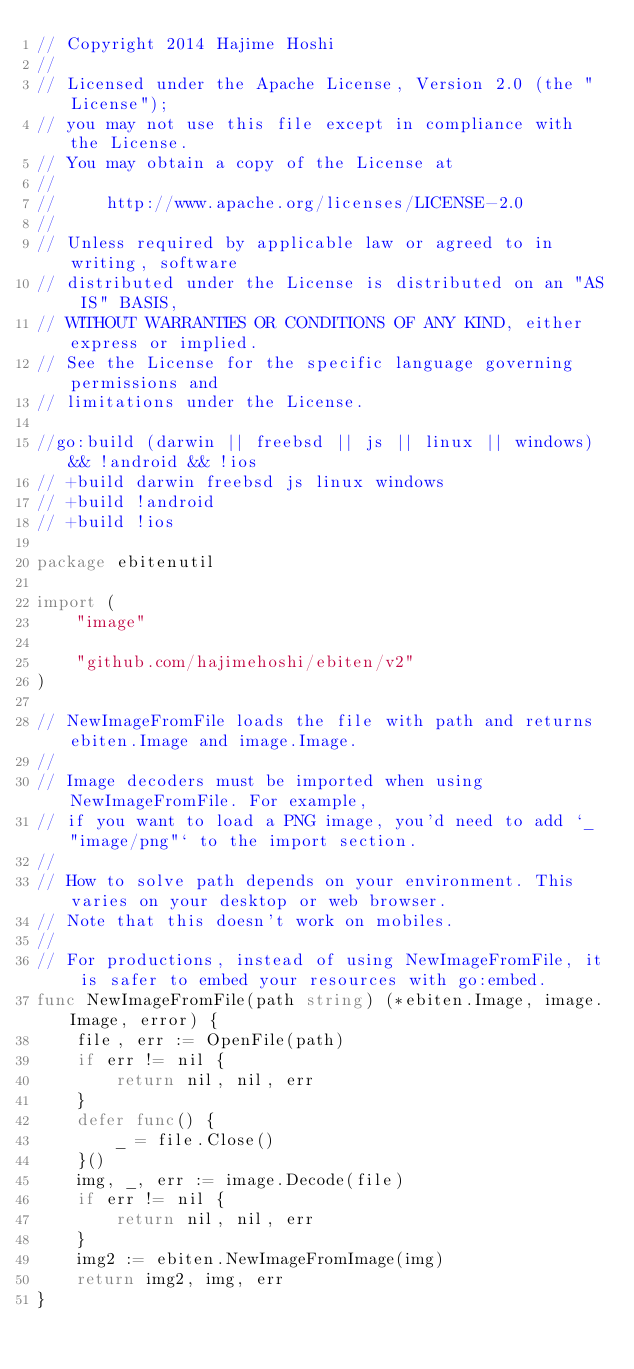Convert code to text. <code><loc_0><loc_0><loc_500><loc_500><_Go_>// Copyright 2014 Hajime Hoshi
//
// Licensed under the Apache License, Version 2.0 (the "License");
// you may not use this file except in compliance with the License.
// You may obtain a copy of the License at
//
//     http://www.apache.org/licenses/LICENSE-2.0
//
// Unless required by applicable law or agreed to in writing, software
// distributed under the License is distributed on an "AS IS" BASIS,
// WITHOUT WARRANTIES OR CONDITIONS OF ANY KIND, either express or implied.
// See the License for the specific language governing permissions and
// limitations under the License.

//go:build (darwin || freebsd || js || linux || windows) && !android && !ios
// +build darwin freebsd js linux windows
// +build !android
// +build !ios

package ebitenutil

import (
	"image"

	"github.com/hajimehoshi/ebiten/v2"
)

// NewImageFromFile loads the file with path and returns ebiten.Image and image.Image.
//
// Image decoders must be imported when using NewImageFromFile. For example,
// if you want to load a PNG image, you'd need to add `_ "image/png"` to the import section.
//
// How to solve path depends on your environment. This varies on your desktop or web browser.
// Note that this doesn't work on mobiles.
//
// For productions, instead of using NewImageFromFile, it is safer to embed your resources with go:embed.
func NewImageFromFile(path string) (*ebiten.Image, image.Image, error) {
	file, err := OpenFile(path)
	if err != nil {
		return nil, nil, err
	}
	defer func() {
		_ = file.Close()
	}()
	img, _, err := image.Decode(file)
	if err != nil {
		return nil, nil, err
	}
	img2 := ebiten.NewImageFromImage(img)
	return img2, img, err
}
</code> 